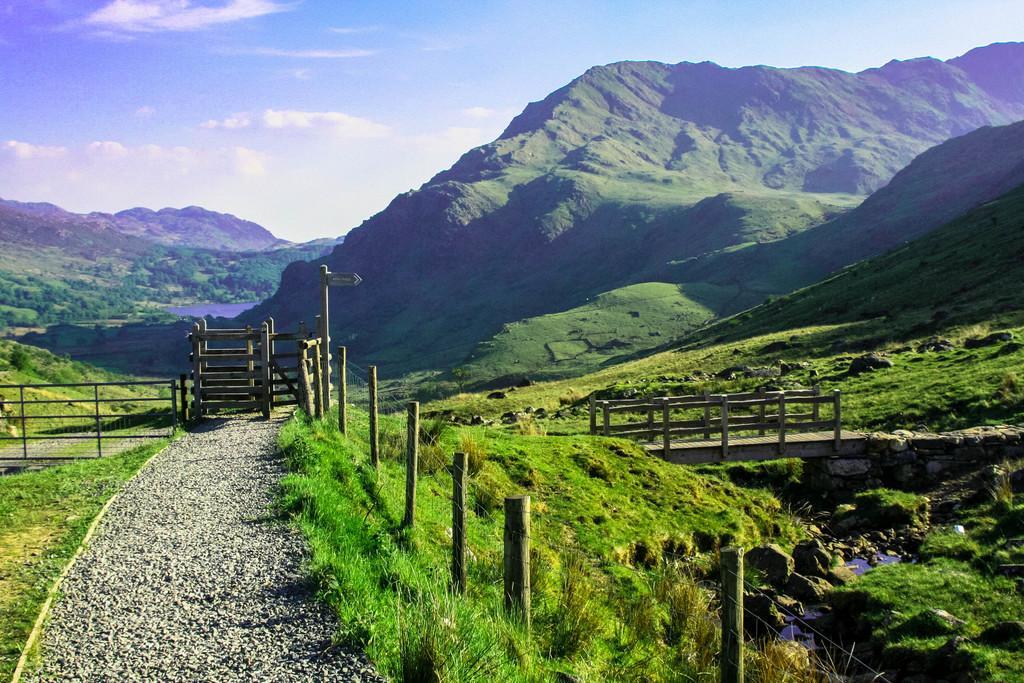Describe this image in one or two sentences. In this image on the left side we can see the road and on the right side we can see the bridge, in the middle we can see mountains in the background we can see the clouds and sky. 